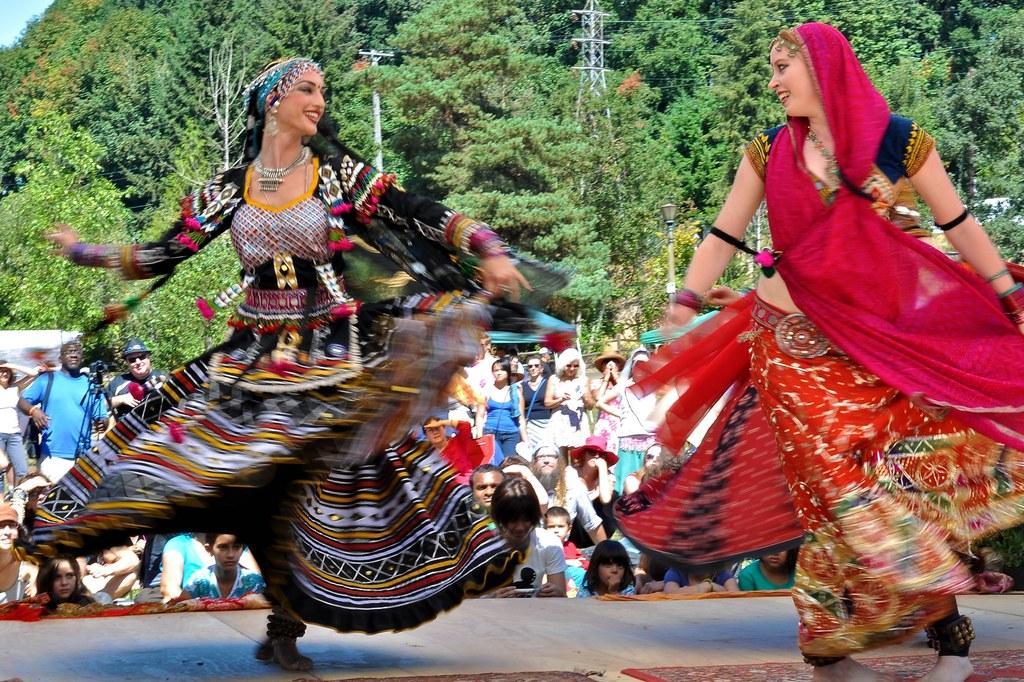Could you give a brief overview of what you see in this image? In the center of the image there are women standing and performing on dais. In the background we can see crowd, tower, pole and trees. 